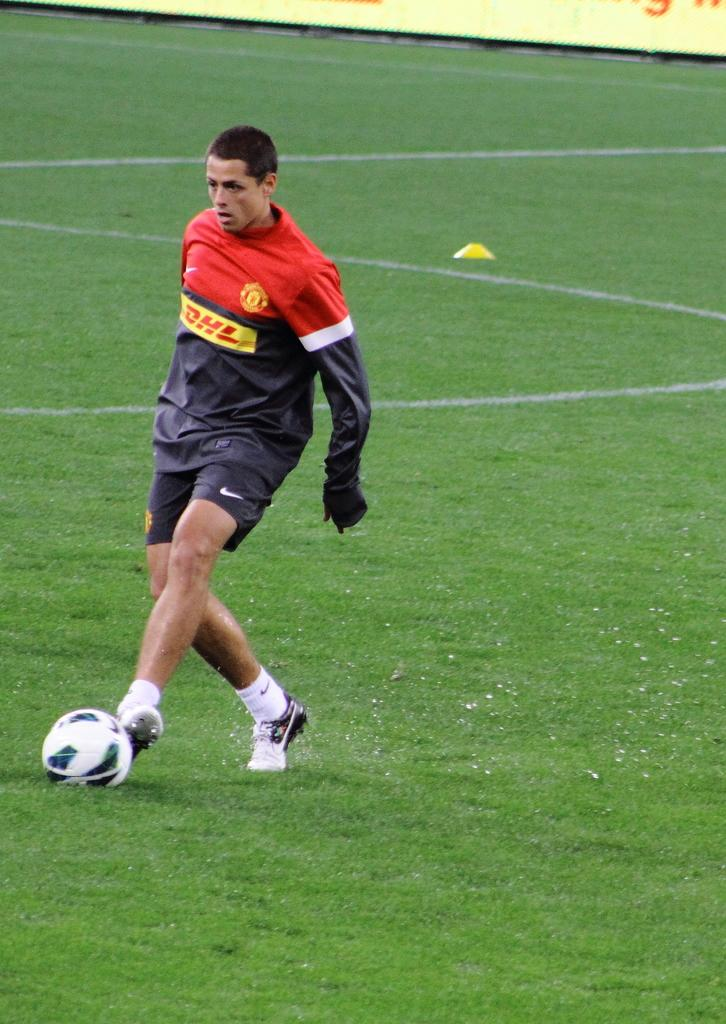Who is the main subject in the image? There is a man in the image. What is the man doing in the image? The man is playing football. Where is the football being played in the image? The football is being played on the ground. What type of pie is being served under the umbrella in the image? There is no pie or umbrella present in the image; it features a man playing football on the ground. 